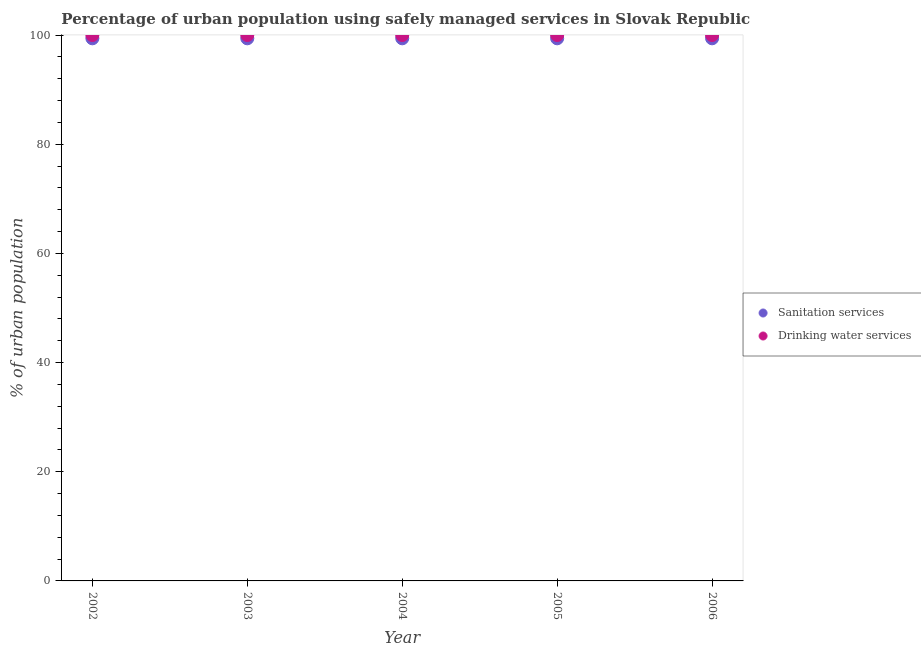What is the percentage of urban population who used drinking water services in 2003?
Your answer should be very brief. 100. Across all years, what is the maximum percentage of urban population who used sanitation services?
Provide a succinct answer. 99.4. Across all years, what is the minimum percentage of urban population who used drinking water services?
Make the answer very short. 100. In which year was the percentage of urban population who used sanitation services maximum?
Your response must be concise. 2002. In which year was the percentage of urban population who used sanitation services minimum?
Your answer should be very brief. 2002. What is the total percentage of urban population who used sanitation services in the graph?
Ensure brevity in your answer.  497. What is the difference between the percentage of urban population who used sanitation services in 2002 and that in 2004?
Make the answer very short. 0. What is the difference between the percentage of urban population who used drinking water services in 2003 and the percentage of urban population who used sanitation services in 2004?
Ensure brevity in your answer.  0.6. What is the average percentage of urban population who used sanitation services per year?
Your answer should be very brief. 99.4. In the year 2006, what is the difference between the percentage of urban population who used sanitation services and percentage of urban population who used drinking water services?
Provide a short and direct response. -0.6. In how many years, is the percentage of urban population who used sanitation services greater than 84 %?
Give a very brief answer. 5. What is the ratio of the percentage of urban population who used sanitation services in 2004 to that in 2006?
Offer a very short reply. 1. Is the percentage of urban population who used drinking water services in 2003 less than that in 2005?
Offer a terse response. No. What is the difference between the highest and the second highest percentage of urban population who used drinking water services?
Your answer should be compact. 0. In how many years, is the percentage of urban population who used sanitation services greater than the average percentage of urban population who used sanitation services taken over all years?
Keep it short and to the point. 0. Does the percentage of urban population who used sanitation services monotonically increase over the years?
Give a very brief answer. No. Is the percentage of urban population who used drinking water services strictly less than the percentage of urban population who used sanitation services over the years?
Provide a succinct answer. No. What is the difference between two consecutive major ticks on the Y-axis?
Keep it short and to the point. 20. Does the graph contain grids?
Make the answer very short. No. How are the legend labels stacked?
Provide a succinct answer. Vertical. What is the title of the graph?
Ensure brevity in your answer.  Percentage of urban population using safely managed services in Slovak Republic. What is the label or title of the X-axis?
Offer a very short reply. Year. What is the label or title of the Y-axis?
Provide a succinct answer. % of urban population. What is the % of urban population of Sanitation services in 2002?
Provide a succinct answer. 99.4. What is the % of urban population in Drinking water services in 2002?
Offer a very short reply. 100. What is the % of urban population of Sanitation services in 2003?
Your answer should be very brief. 99.4. What is the % of urban population of Sanitation services in 2004?
Offer a very short reply. 99.4. What is the % of urban population of Sanitation services in 2005?
Ensure brevity in your answer.  99.4. What is the % of urban population of Sanitation services in 2006?
Give a very brief answer. 99.4. What is the % of urban population of Drinking water services in 2006?
Ensure brevity in your answer.  100. Across all years, what is the maximum % of urban population in Sanitation services?
Make the answer very short. 99.4. Across all years, what is the minimum % of urban population of Sanitation services?
Offer a very short reply. 99.4. What is the total % of urban population in Sanitation services in the graph?
Your answer should be compact. 497. What is the total % of urban population in Drinking water services in the graph?
Ensure brevity in your answer.  500. What is the difference between the % of urban population of Sanitation services in 2002 and that in 2003?
Offer a terse response. 0. What is the difference between the % of urban population of Sanitation services in 2002 and that in 2004?
Offer a terse response. 0. What is the difference between the % of urban population in Drinking water services in 2002 and that in 2004?
Keep it short and to the point. 0. What is the difference between the % of urban population in Drinking water services in 2002 and that in 2005?
Provide a short and direct response. 0. What is the difference between the % of urban population in Sanitation services in 2002 and that in 2006?
Make the answer very short. 0. What is the difference between the % of urban population in Sanitation services in 2003 and that in 2004?
Keep it short and to the point. 0. What is the difference between the % of urban population in Sanitation services in 2003 and that in 2005?
Your answer should be very brief. 0. What is the difference between the % of urban population in Drinking water services in 2003 and that in 2005?
Ensure brevity in your answer.  0. What is the difference between the % of urban population of Sanitation services in 2004 and that in 2005?
Make the answer very short. 0. What is the difference between the % of urban population in Drinking water services in 2004 and that in 2005?
Give a very brief answer. 0. What is the difference between the % of urban population of Drinking water services in 2004 and that in 2006?
Ensure brevity in your answer.  0. What is the difference between the % of urban population in Drinking water services in 2005 and that in 2006?
Provide a succinct answer. 0. What is the difference between the % of urban population of Sanitation services in 2002 and the % of urban population of Drinking water services in 2003?
Keep it short and to the point. -0.6. What is the difference between the % of urban population in Sanitation services in 2002 and the % of urban population in Drinking water services in 2005?
Your answer should be very brief. -0.6. What is the difference between the % of urban population of Sanitation services in 2002 and the % of urban population of Drinking water services in 2006?
Provide a succinct answer. -0.6. What is the difference between the % of urban population of Sanitation services in 2003 and the % of urban population of Drinking water services in 2004?
Provide a succinct answer. -0.6. What is the difference between the % of urban population of Sanitation services in 2003 and the % of urban population of Drinking water services in 2006?
Ensure brevity in your answer.  -0.6. What is the difference between the % of urban population of Sanitation services in 2004 and the % of urban population of Drinking water services in 2005?
Make the answer very short. -0.6. What is the difference between the % of urban population of Sanitation services in 2005 and the % of urban population of Drinking water services in 2006?
Ensure brevity in your answer.  -0.6. What is the average % of urban population of Sanitation services per year?
Provide a succinct answer. 99.4. In the year 2002, what is the difference between the % of urban population of Sanitation services and % of urban population of Drinking water services?
Provide a short and direct response. -0.6. In the year 2003, what is the difference between the % of urban population in Sanitation services and % of urban population in Drinking water services?
Offer a very short reply. -0.6. In the year 2005, what is the difference between the % of urban population in Sanitation services and % of urban population in Drinking water services?
Provide a succinct answer. -0.6. What is the ratio of the % of urban population in Sanitation services in 2002 to that in 2003?
Your answer should be very brief. 1. What is the ratio of the % of urban population of Sanitation services in 2002 to that in 2004?
Give a very brief answer. 1. What is the ratio of the % of urban population of Drinking water services in 2002 to that in 2004?
Ensure brevity in your answer.  1. What is the ratio of the % of urban population in Sanitation services in 2002 to that in 2005?
Provide a short and direct response. 1. What is the ratio of the % of urban population in Drinking water services in 2002 to that in 2005?
Your response must be concise. 1. What is the ratio of the % of urban population in Sanitation services in 2002 to that in 2006?
Offer a very short reply. 1. What is the ratio of the % of urban population of Drinking water services in 2002 to that in 2006?
Your answer should be compact. 1. What is the ratio of the % of urban population in Sanitation services in 2003 to that in 2004?
Provide a short and direct response. 1. What is the ratio of the % of urban population in Sanitation services in 2003 to that in 2005?
Ensure brevity in your answer.  1. What is the ratio of the % of urban population in Drinking water services in 2003 to that in 2005?
Your answer should be very brief. 1. What is the ratio of the % of urban population of Sanitation services in 2003 to that in 2006?
Provide a succinct answer. 1. What is the ratio of the % of urban population of Drinking water services in 2003 to that in 2006?
Your answer should be very brief. 1. What is the ratio of the % of urban population in Sanitation services in 2004 to that in 2005?
Your response must be concise. 1. What is the difference between the highest and the second highest % of urban population in Sanitation services?
Your response must be concise. 0. What is the difference between the highest and the lowest % of urban population of Sanitation services?
Your response must be concise. 0. 